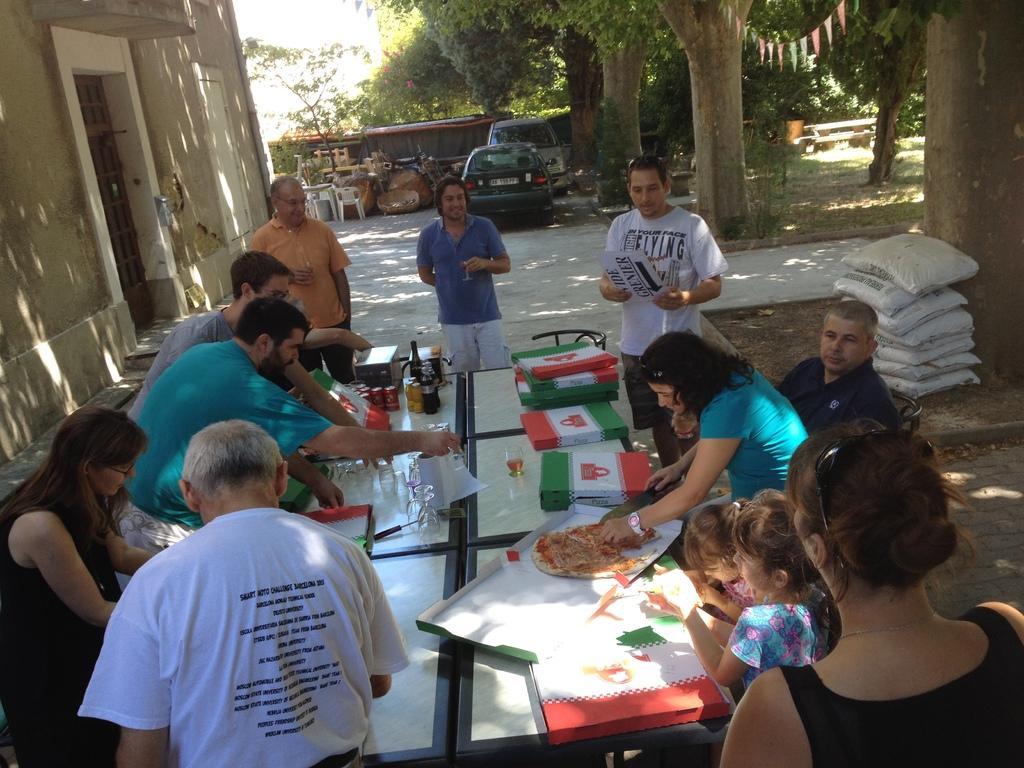Describe this image in one or two sentences. Some people gathered around a table. A woman is cutting a Pizza. There are few children beside her. There are two cars at a distance. There are some trees in the surroundings. 